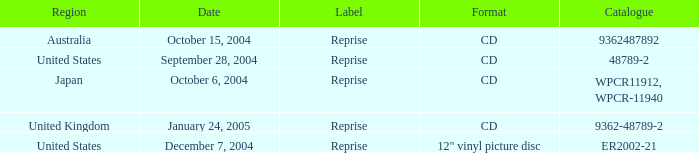Name the region for december 7, 2004 United States. 